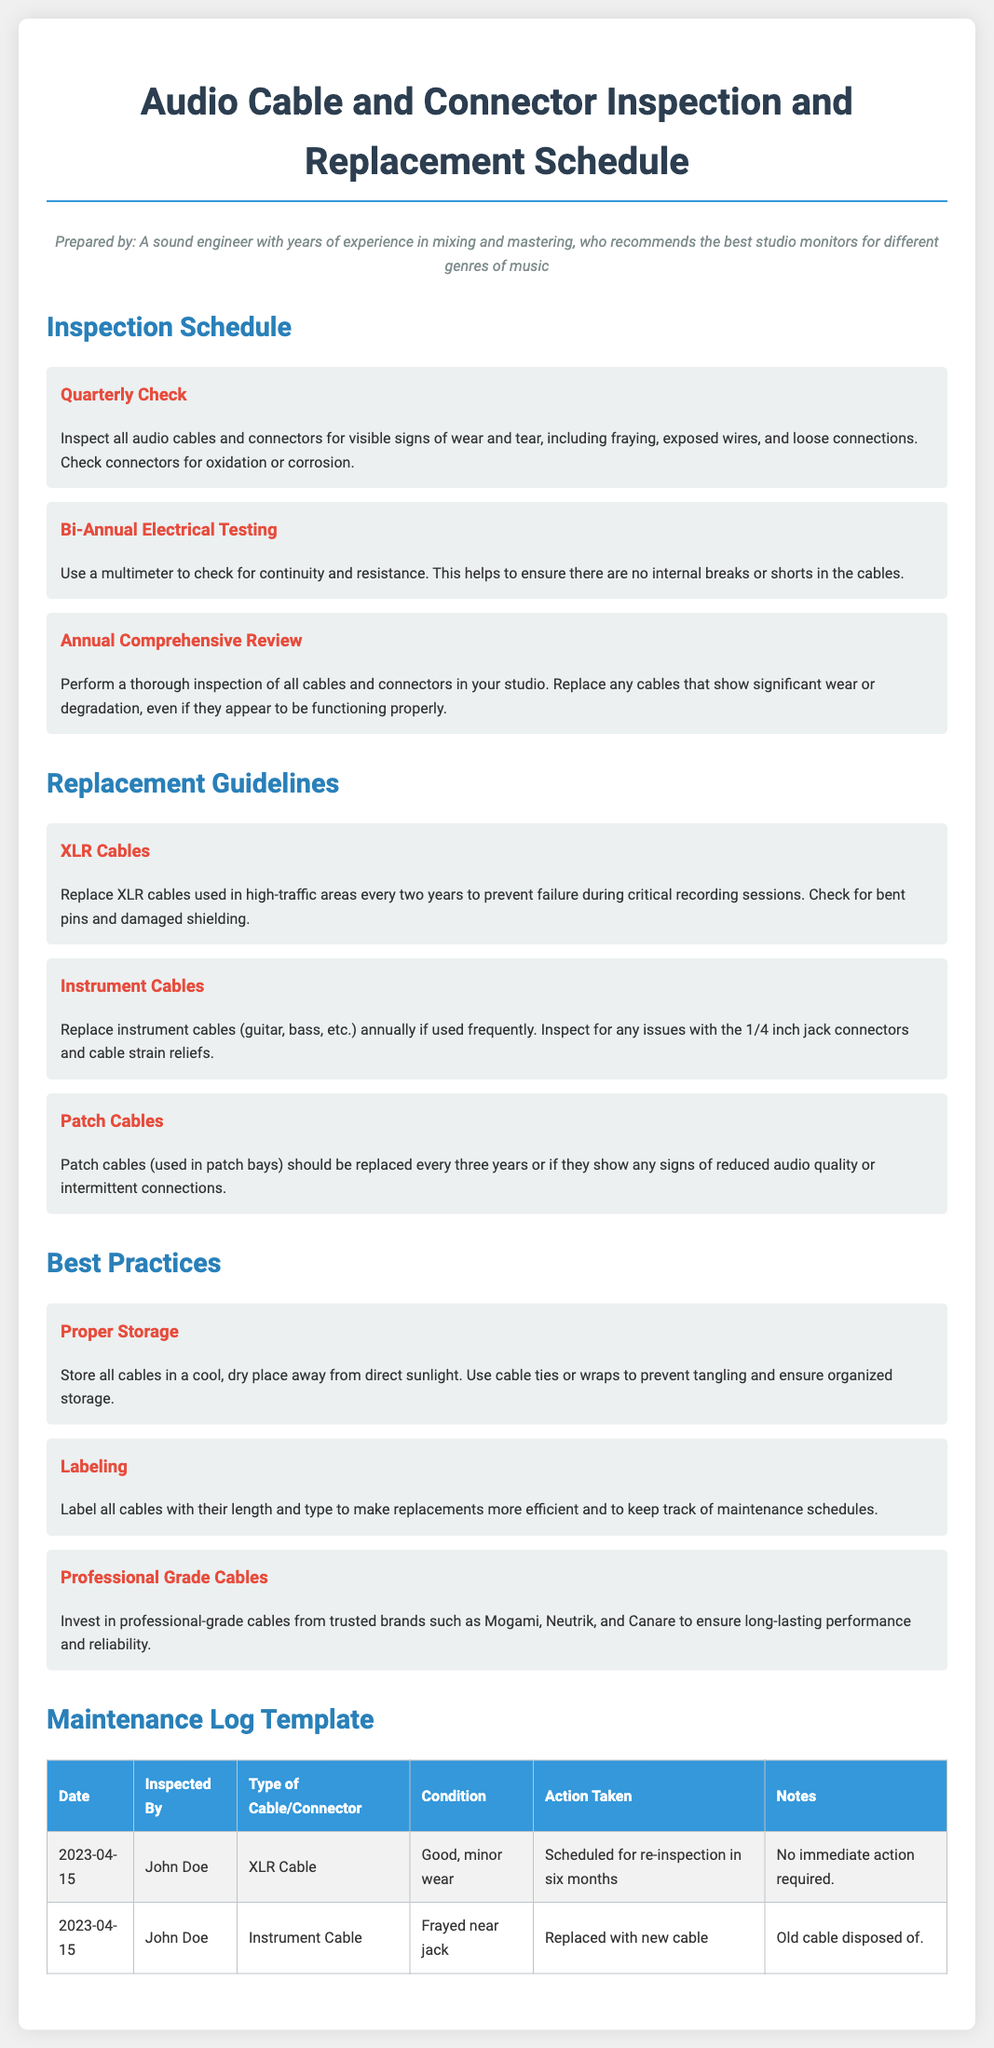What is the title of the document? The title is displayed prominently at the top of the document.
Answer: Audio Cable and Connector Inspection and Replacement Schedule What is the inspection frequency for XLR cables? The document states that XLR cables used in high-traffic areas should be replaced every two years.
Answer: Every two years Who prepared the document? The author is identified in the persona section of the document.
Answer: A sound engineer What kind of testing is performed bi-annually? The document specifies the type of testing for cables during a bi-annual schedule.
Answer: Electrical Testing What is the condition noted on the instrument cable in the maintenance log? The log indicates the specific condition of the instrument cable inspected.
Answer: Frayed near jack How often should patch cables be replaced? The document includes specific replacement guidelines for patch cables.
Answer: Every three years What tool is used to check for continuity? The inspection process mentions the specific tool used for electrical checks.
Answer: Multimeter What should be labeled on all cables? The document provides guidance on what information should be included for cable management.
Answer: Length and type 